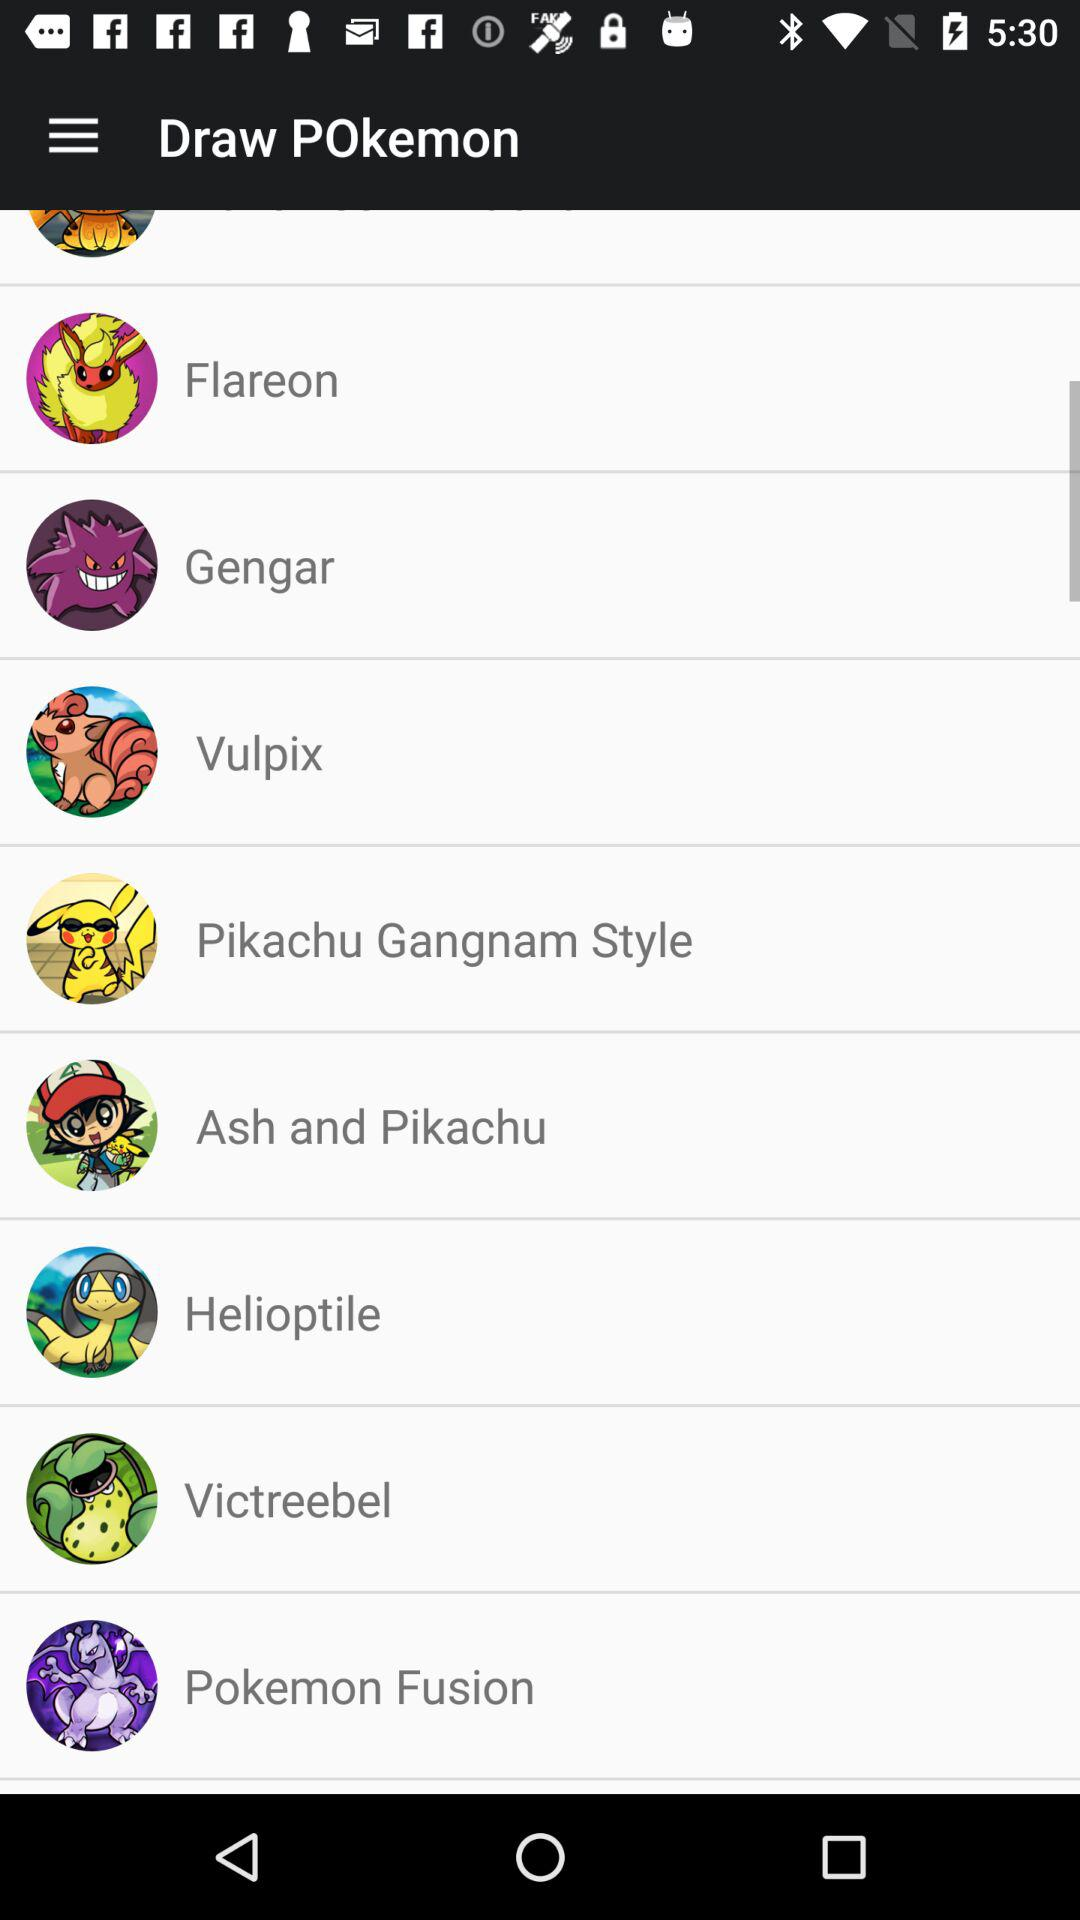What are the different "Draw POkemon" options available? The available options are "Flareon", "Gengar", "Vulpix", "Pikachu Gangnam Style", "Ash and Pikachu", "Helioptile", "Victreebel" and "Pokemon Fusion". 